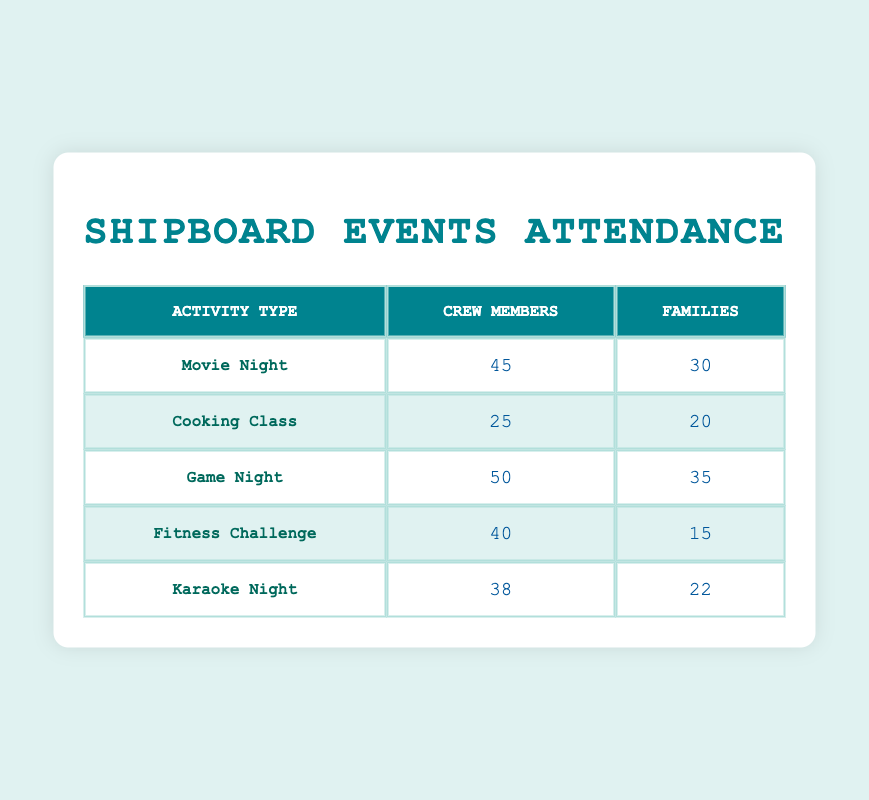What is the attendance for Movie Night among Crew Members? The table shows the attendance for Movie Night specifically under the "Crew Members" demographic. The attendance is listed as 45.
Answer: 45 Which activity had the highest attendance from Families? By reviewing the Families' attendance column, we can see the following values: Movie Night (30), Cooking Class (20), Game Night (35), Fitness Challenge (15), Karaoke Night (22). The highest value is 35 for Game Night.
Answer: 35 What is the total attendance for Cooking Class among both demographics? To find the total attendance for Cooking Class, we need to add the attendance figures from both Crew Members (25) and Families (20), which gives us 25 + 20 = 45.
Answer: 45 Is the attendance for Game Night higher than the attendance for Karaoke Night among Crew Members? Looking at the attendance figures for Crew Members, Game Night has 50 attendees, while Karaoke Night has 38 attendees. Since 50 is greater than 38, the attendance for Game Night is indeed higher.
Answer: Yes What is the average attendance for Families across all activities? To calculate the average attendance for Families, we add the attendance figures for Families: 30 (Movie Night) + 20 (Cooking Class) + 35 (Game Night) + 15 (Fitness Challenge) + 22 (Karaoke Night) = 122. There are 5 activities, so we divide 122 by 5, resulting in an average of 24.4.
Answer: 24.4 Which activity had the least attendance from Crew Members? From the Crew Members’ attendance, the values are: Movie Night (45), Cooking Class (25), Game Night (50), Fitness Challenge (40), Karaoke Night (38). The least attendance is 25 for Cooking Class.
Answer: Cooking Class What is the difference in attendance between Game Night and Fitness Challenge for Crew Members? Looking at the figures, Game Night has 50 attendees and Fitness Challenge has 40 attendees for Crew Members. The difference is 50 - 40 = 10.
Answer: 10 Did Families attend more to Karaoke Night compared to Fitness Challenge? For Families, the attendance at Karaoke Night is 22 while at Fitness Challenge it is 15. Since 22 is greater than 15, Families did attend more to Karaoke Night.
Answer: Yes 